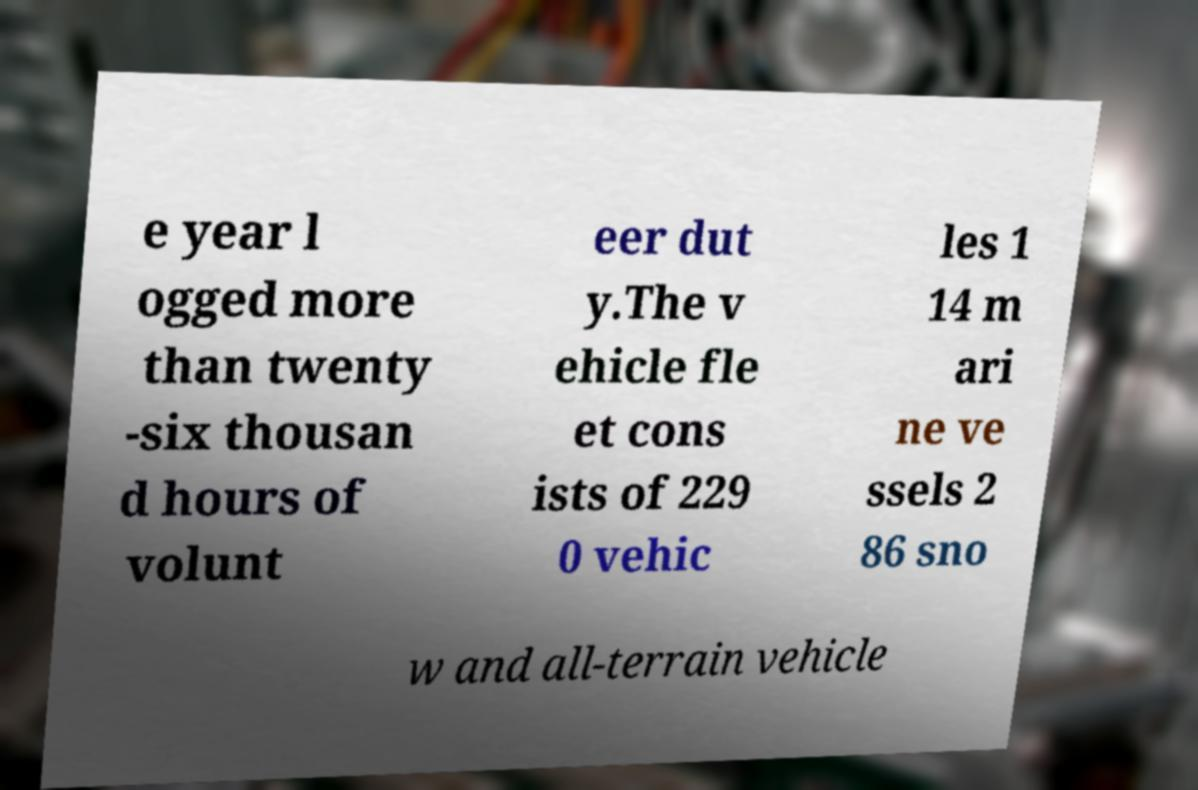What messages or text are displayed in this image? I need them in a readable, typed format. e year l ogged more than twenty -six thousan d hours of volunt eer dut y.The v ehicle fle et cons ists of 229 0 vehic les 1 14 m ari ne ve ssels 2 86 sno w and all-terrain vehicle 